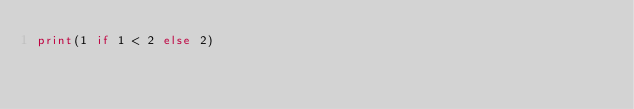Convert code to text. <code><loc_0><loc_0><loc_500><loc_500><_Python_>print(1 if 1 < 2 else 2)</code> 